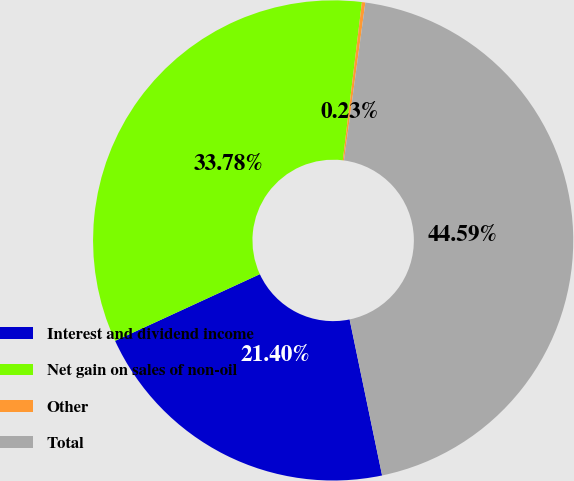Convert chart. <chart><loc_0><loc_0><loc_500><loc_500><pie_chart><fcel>Interest and dividend income<fcel>Net gain on sales of non-oil<fcel>Other<fcel>Total<nl><fcel>21.4%<fcel>33.78%<fcel>0.23%<fcel>44.59%<nl></chart> 